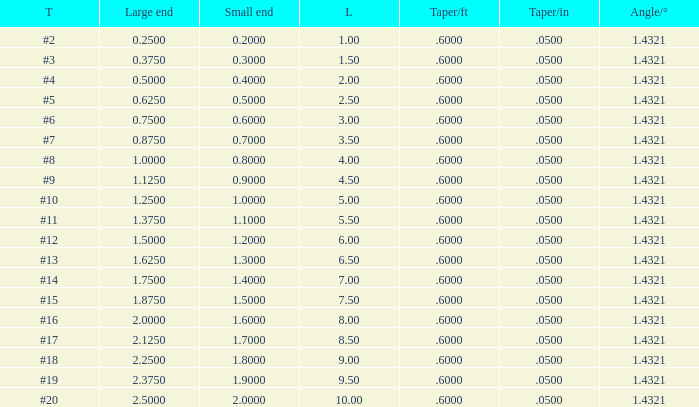Which Taper/in that has a Small end larger than 0.7000000000000001, and a Taper of #19, and a Large end larger than 2.375? None. 